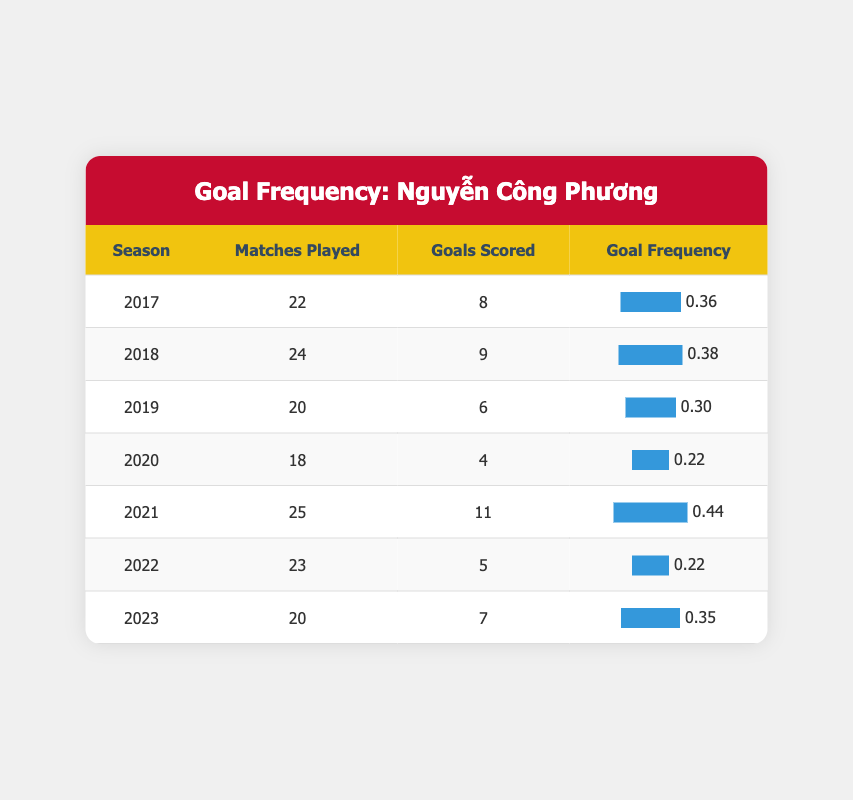What is the highest number of goals scored by Nguyễn Công Phương in a season? In the table, I will look through the "Goals Scored" column and identify the highest value. The seasons show goals scored as follows: 8, 9, 6, 4, 11, 5, and 7. The highest among these is 11, which is from the 2021 season.
Answer: 11 In which season did Nguyễn Công Phương score the least number of goals? To find the season with the least goals, I will review the "Goals Scored" column. The values are 8, 9, 6, 4, 11, 5, and 7. The lowest score is 4 in the 2020 season.
Answer: 2020 What is the average number of goals scored per season by Nguyễn Công Phương? First, I will add the total number of goals scored across all seasons: 8 + 9 + 6 + 4 + 11 + 5 + 7 = 50. There are 7 seasons, so I divide 50 by 7, which gives approximately 7.14.
Answer: 7.14 Did Nguyễn Công Phương score more than 10 goals in any season? I will check the "Goals Scored" column for any values greater than 10. The only recorded values are 8, 9, 6, 4, 11, 5, and 7. Since 11 is present, the answer is yes.
Answer: Yes In which years did Nguyễn Công Phương play a total of 21 or more matches? I will check the "Matches Played" column for seasons with a value of 21 or higher. The seasons 2018 (24), 2021 (25), and 2022 (23) meet this criteria. Therefore, he played at least 21 matches in these years.
Answer: 2018, 2021, 2022 What is the goal frequency for the 2019 season? I will locate the 2019 season in the table, where Nguyễn Công Phương scored 6 goals in 20 matches. The goal frequency is calculated as goals scored divided by matches played, which is 6/20 = 0.30.
Answer: 0.30 How does the goal frequency in 2021 compare to that in 2018? I will first note the goal frequency for both years. In 2021, he scored 11 goals in 25 matches, leading to a frequency of 0.44. In 2018, he scored 9 goals in 24 matches, resulting in a frequency of 0.375. Comparing, 0.44 is greater than 0.375, hence 2021 had a higher frequency.
Answer: 2021 had a higher frequency What is the total number of matches played by Nguyễn Công Phương over these seasons? I will sum the "Matches Played" column: 22 + 24 + 20 + 18 + 25 + 23 + 20 = 172.
Answer: 172 Which two seasons combined had the highest total goals scored? I will look at all combinations of the seasons and their goals: 2017 (8) + 2018 (9) = 17; 2017 (8) + 2021 (11) = 19; 2018 (9) + 2021 (11) = 20; and so forth. Comparing them all, 2018 and 2021 yield 20, which is the highest total for any combination.
Answer: 2018 and 2021 